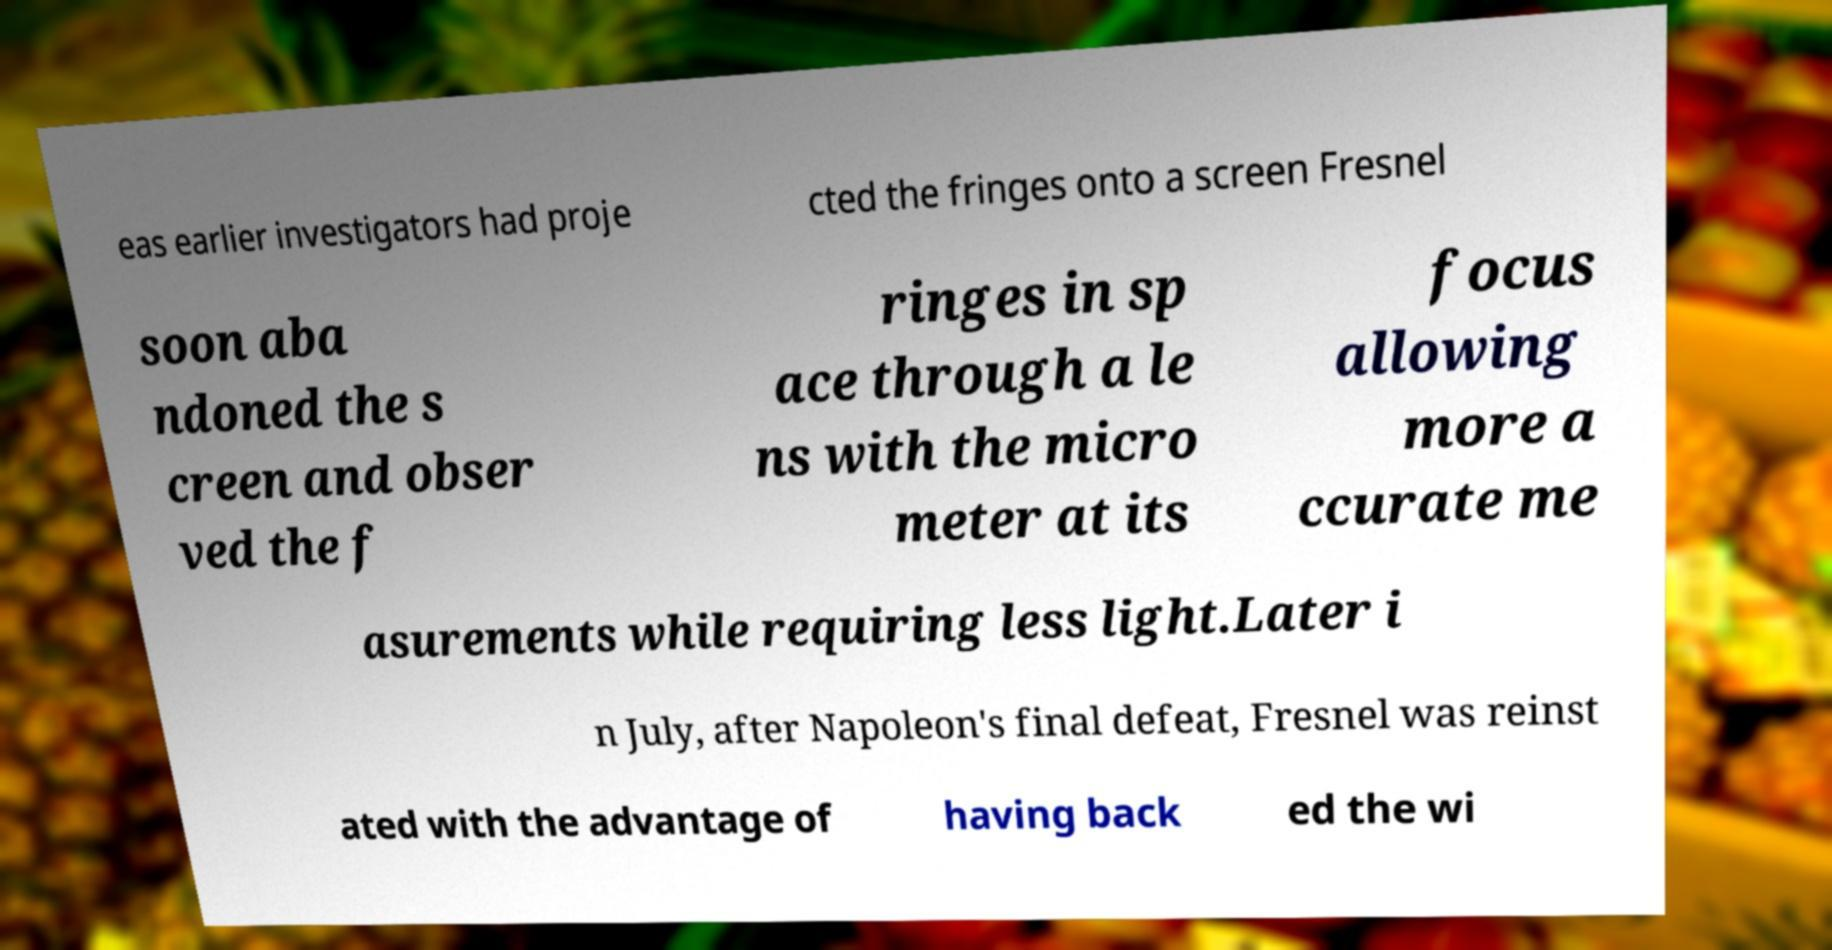Could you assist in decoding the text presented in this image and type it out clearly? eas earlier investigators had proje cted the fringes onto a screen Fresnel soon aba ndoned the s creen and obser ved the f ringes in sp ace through a le ns with the micro meter at its focus allowing more a ccurate me asurements while requiring less light.Later i n July, after Napoleon's final defeat, Fresnel was reinst ated with the advantage of having back ed the wi 